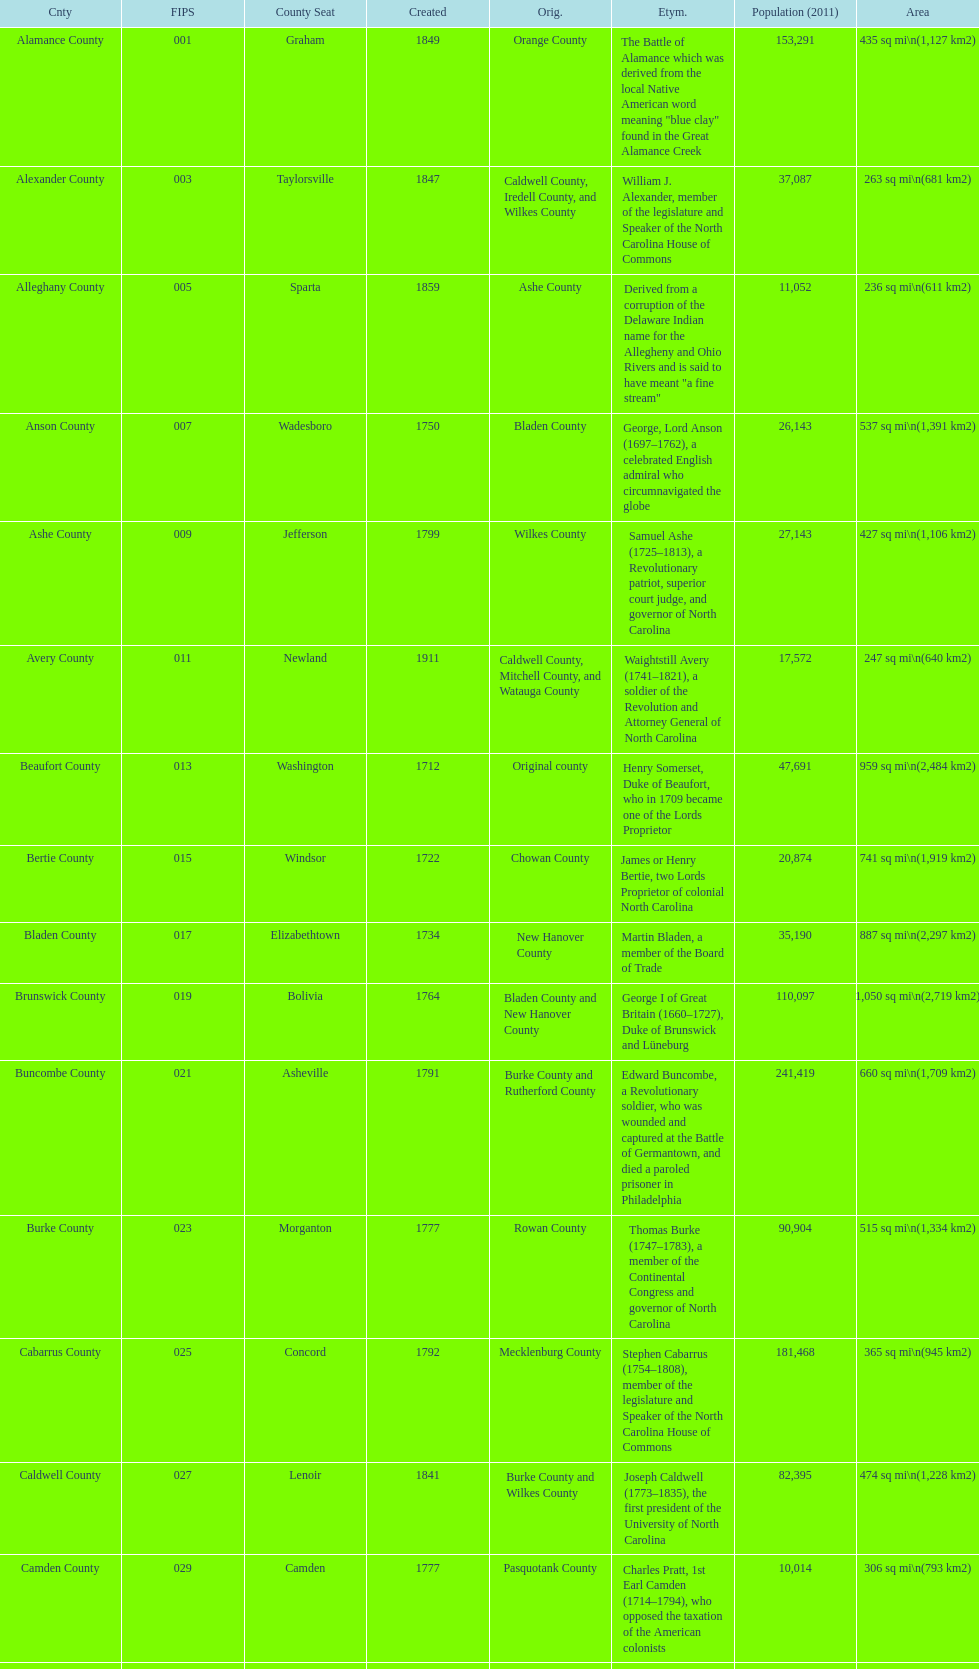Which county has a higher population, alamance or alexander? Alamance County. 